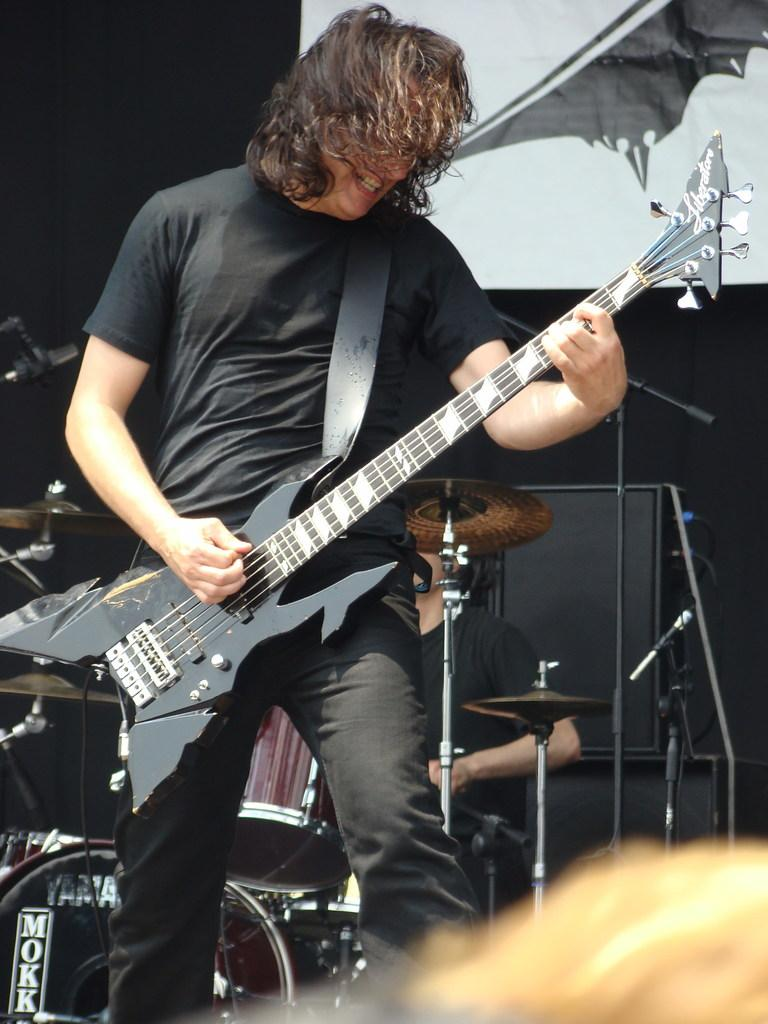What is the man in the image doing? The man in the image is standing and playing a guitar. Can you describe the other person in the image? The other person in the image is seated and playing drums. What type of cream is being used by the man playing the guitar in the image? There is no cream present in the image; the man is playing a guitar. 